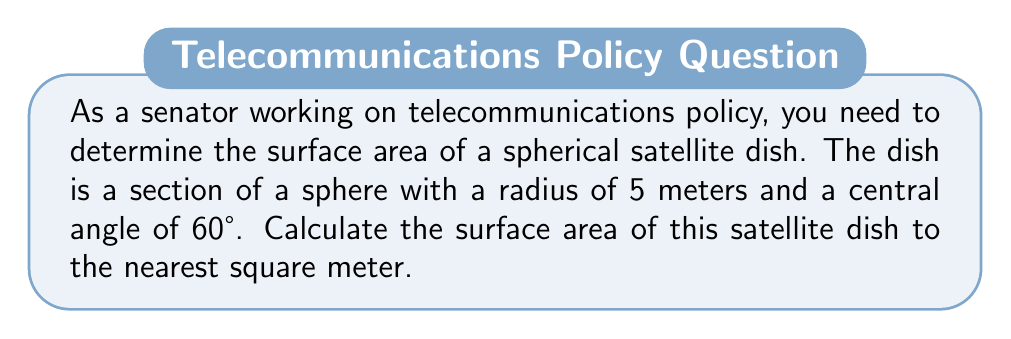Can you solve this math problem? To solve this problem, we need to use the formula for the surface area of a spherical cap. Let's break it down step-by-step:

1) The formula for the surface area of a spherical cap is:

   $$ A = 2\pi r h $$

   where $A$ is the surface area, $r$ is the radius of the sphere, and $h$ is the height of the cap.

2) We're given the radius $r = 5$ meters and the central angle $\theta = 60°$. We need to find $h$.

3) To find $h$, we can use the formula:

   $$ h = r(1 - \cos(\frac{\theta}{2})) $$

4) Let's calculate $h$:
   
   $$ h = 5(1 - \cos(30°)) $$
   $$ h = 5(1 - \frac{\sqrt{3}}{2}) $$
   $$ h = 5(1 - 0.866) $$
   $$ h = 5(0.134) = 0.67 \text{ meters} $$

5) Now we can plug this into our surface area formula:

   $$ A = 2\pi r h $$
   $$ A = 2\pi (5)(0.67) $$
   $$ A = 10\pi(0.67) $$
   $$ A = 21.048 \text{ square meters} $$

6) Rounding to the nearest square meter:

   $$ A \approx 21 \text{ square meters} $$

[asy]
import geometry;

size(200);
pair O=(0,0);
real r=5;
real theta=pi/3;
draw(circle(O,r));
draw(O--r*dir(90));
draw(O--r*dir(90-theta));
draw(arc(O,r*dir(90),r*dir(90-theta)));
label("$r$",O--0.5r*dir(45),NE);
label("$\theta$",0.3r*dir(90-theta/2),NE);
label("$h$",r*dir(90)--r*dir(90-theta),E);
[/asy]
Answer: The surface area of the spherical satellite dish is approximately 21 square meters. 